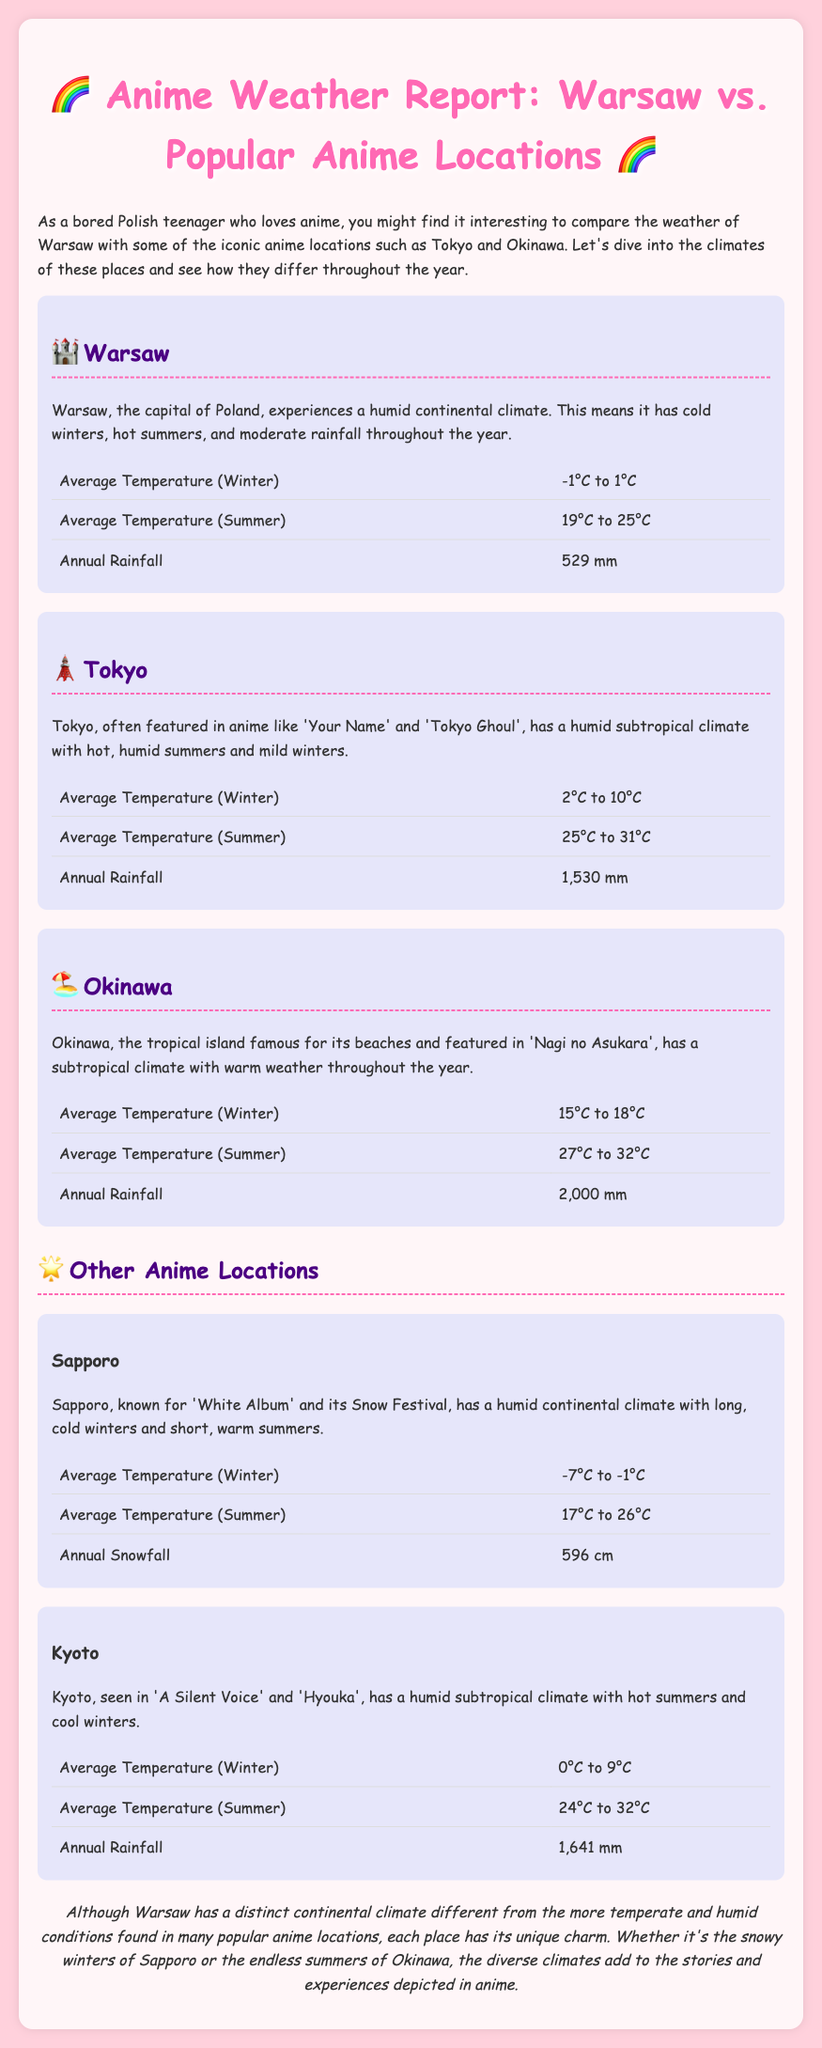What is Warsaw's average temperature in winter? The document states that Warsaw's average temperature in winter ranges from -1°C to 1°C.
Answer: -1°C to 1°C What is Tokyo's annual rainfall? According to the document, Tokyo has an annual rainfall of 1,530 mm.
Answer: 1,530 mm What type of climate does Okinawa have? The document describes Okinawa as having a subtropical climate.
Answer: Subtropical What is the average temperature range for Kyoto in summer? The document indicates Kyoto's average temperature in summer is between 24°C and 32°C.
Answer: 24°C to 32°C Which anime location has the highest annual rainfall? The document provides that Okinawa has the highest annual rainfall at 2,000 mm among the locations listed.
Answer: Okinawa What distinguishes Warsaw from the other locations in terms of climate? The document notes that Warsaw has a humid continental climate, while other locations generally have humid subtropical climates.
Answer: Humid continental climate What is the average snowfall in Sapporo? The document reports that Sapporo has an annual snowfall of 596 cm.
Answer: 596 cm Which anime is featured in Okinawa? The document mentions 'Nagi no Asukara' as the anime featured in Okinawa.
Answer: Nagi no Asukara 